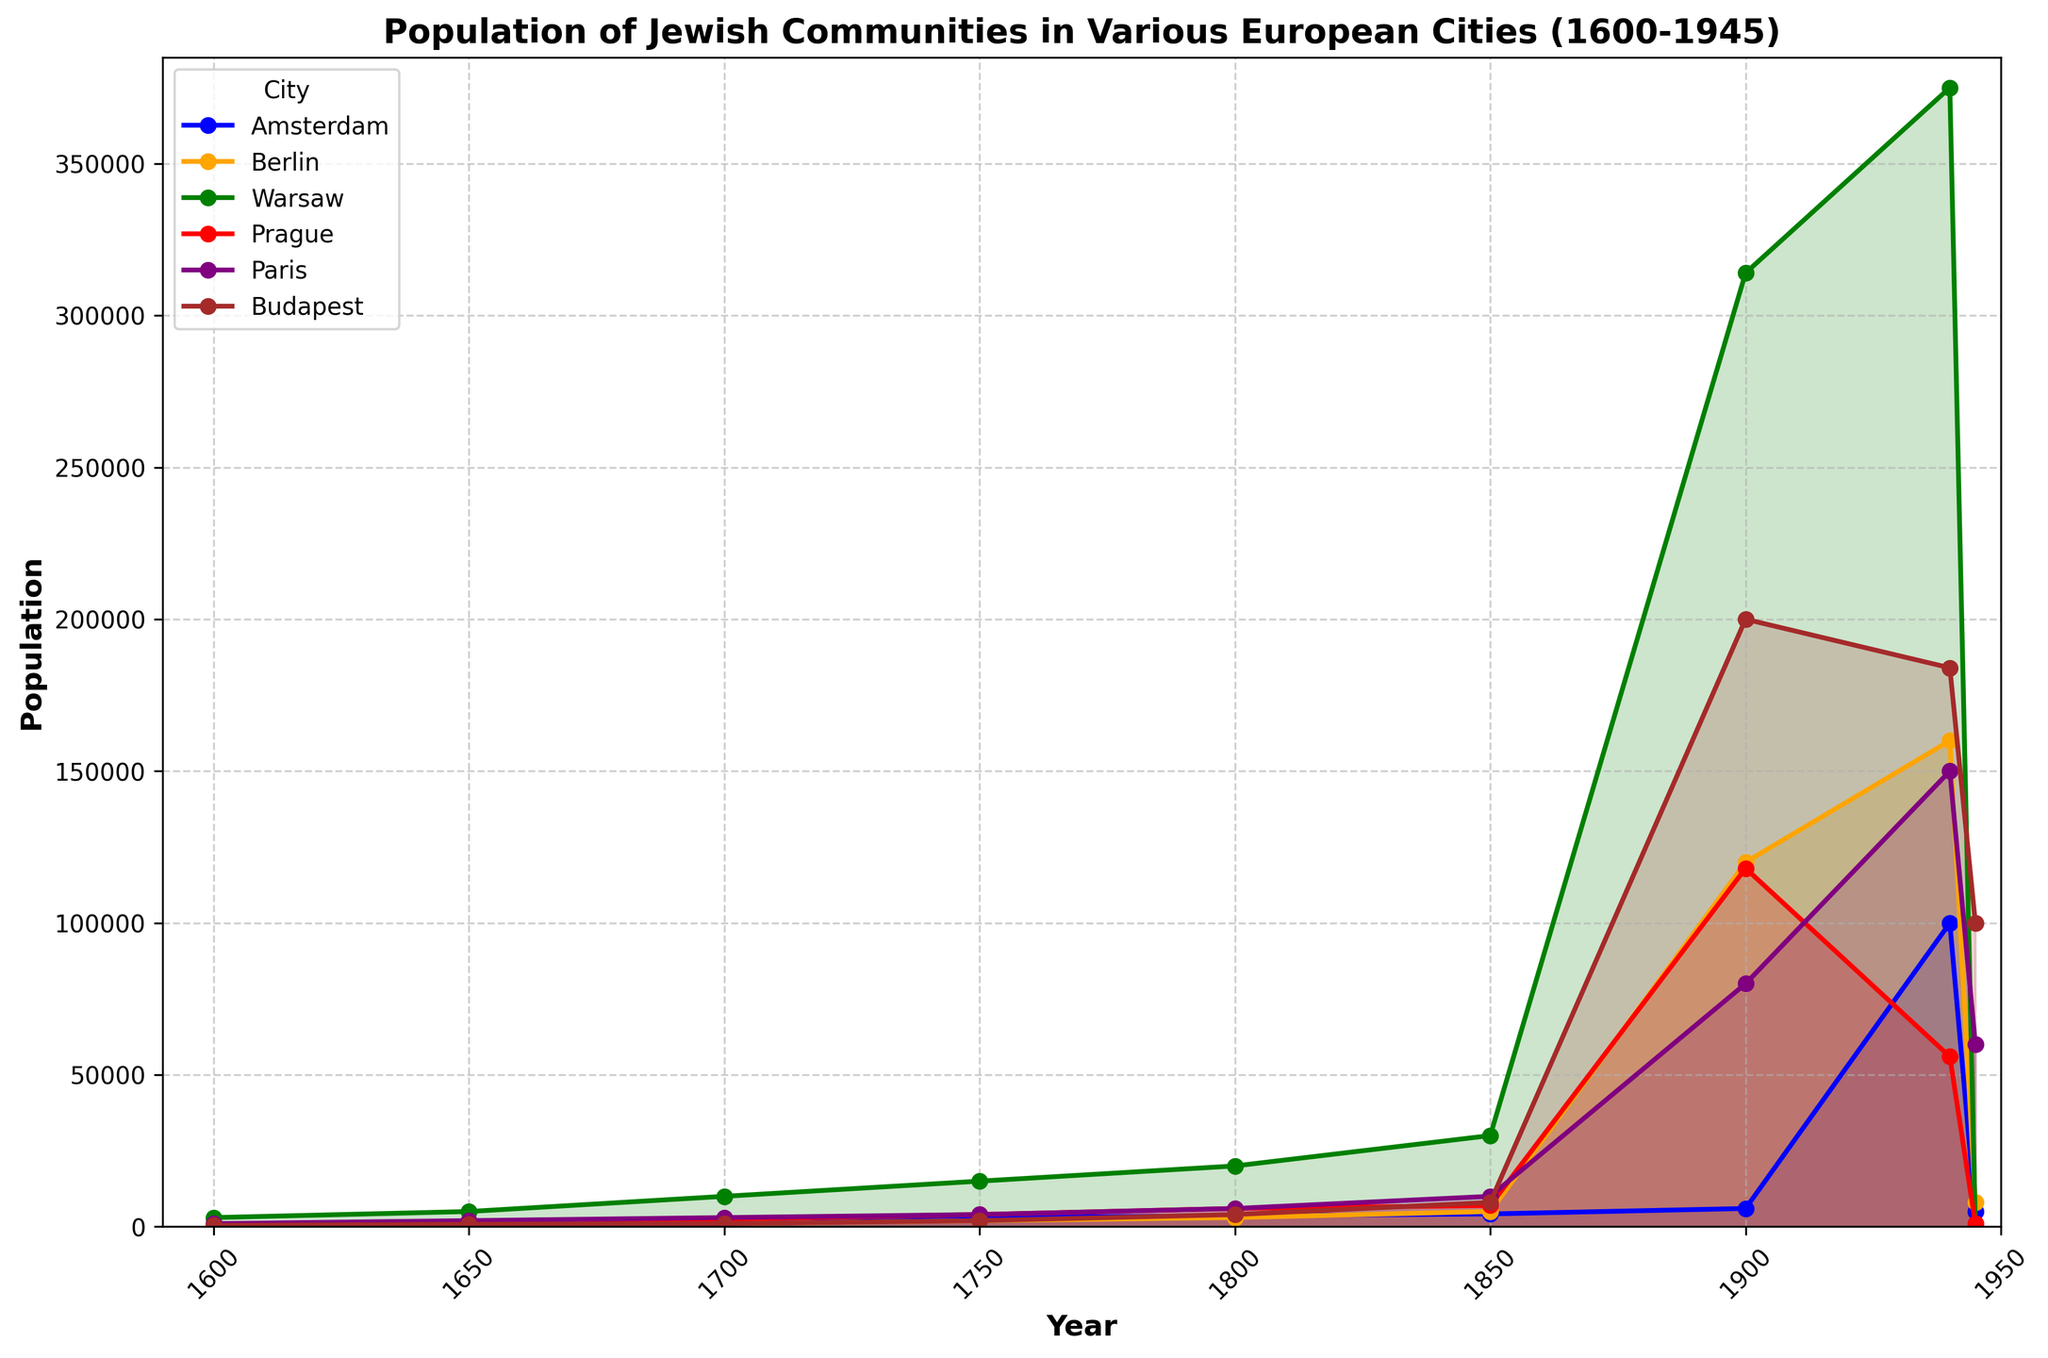Which city had the highest Jewish population in 1900? To find the city with the highest Jewish population in 1900, look at each city's population at the year 1900. Check the plots and the highest peak at that time. The highest peak is for Warsaw.
Answer: Warsaw What was the Jewish population in Prague in 1945? Look at the plot for Prague (red color) and find the data point for the year 1945. The population value at that point is 1000.
Answer: 1000 How did the Jewish population in Berlin change between 1900 and 1940? Check the population values for Berlin (orange color) in the years 1900 and 1940 and calculate the difference. In 1900, the population was 120,000 and in 1940, it was 160,000. The population increased by 40,000.
Answer: Increased by 40,000 Which city saw the greatest decline in Jewish population between 1940 and 1945? Look at the population values for all cities in the years 1940 and 1945 and compare the decline. Warsaw saw a drop from 375,000 to 0, which is the largest decline.
Answer: Warsaw What is the total Jewish population across all cities in the year 1750? Sum the population values for each city in the year 1750. 
Amsterdam: 3000, Berlin: 2000, Warsaw: 15000, Prague: 4000, Paris: 4000, Budapest: 2000. 
(3000 + 2000 + 15000 + 4000 + 4000 + 2000) = 30,000.
Answer: 30,000 Describe the overall trend in the Jewish population of Amsterdam from 1600 to 1945. Examine the plot for Amsterdam (blue color) over the years 1600 to 1945. Initially, the population increased gradually until 1940, where it peaked at 100,000, followed by a sharp decline to 5,000 by 1945.
Answer: Gradual increase to 1940, then sharp decline By how much did the Jewish population in Paris grow from 1800 to 1900? Check the population values for Paris (purple color) in the years 1800 and 1900 and calculate the difference. In 1800, the population was 6,000, and in 1900, it was 80,000. The population grew by 74,000.
Answer: Grew by 74,000 Which city had the smallest Jewish population in 1600? Look at the population values for each city in the year 1600. The smallest population is for Berlin with 200 people.
Answer: Berlin Between which two cities was the Jewish population closest in 1940? Compare the population values of each city in 1940 and find the closest pair. The populations of Budapest (184,000) and Paris (150,000) are closest to each other with a difference of 34,000.
Answer: Budapest and Paris What was the average Jewish population in Warsaw from 1600 to 1750? Sum the population values of Warsaw for the years 1600, 1650, 1700, and 1750 and divide by the number of data points. 
(3000 + 5000 + 10000 + 15000) / 4 = 82,000 / 4 = 8,250.
Answer: 8,250 